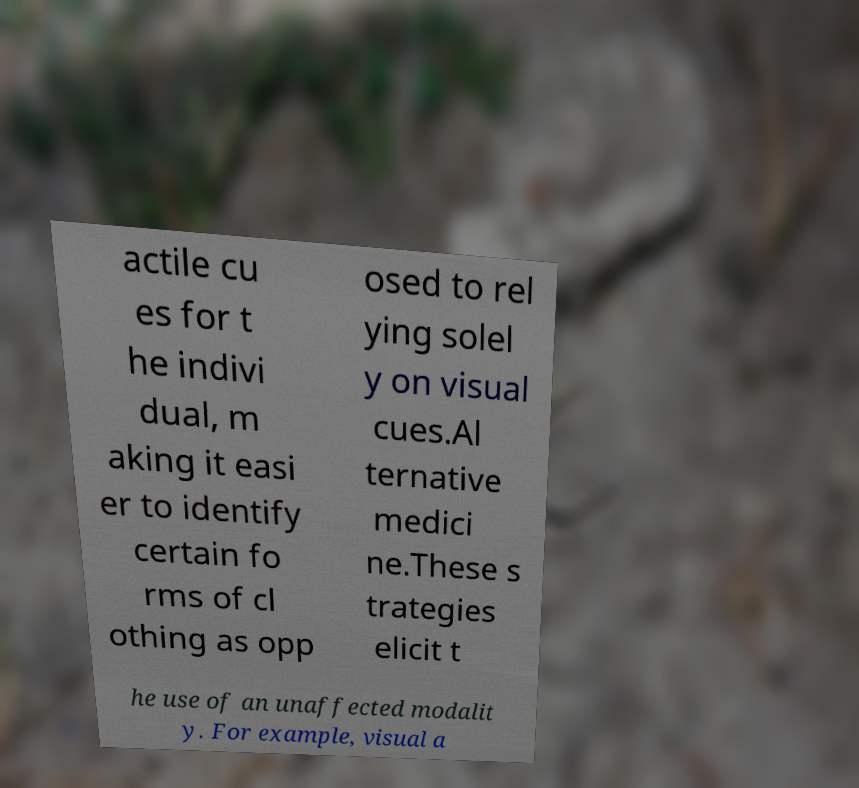What messages or text are displayed in this image? I need them in a readable, typed format. actile cu es for t he indivi dual, m aking it easi er to identify certain fo rms of cl othing as opp osed to rel ying solel y on visual cues.Al ternative medici ne.These s trategies elicit t he use of an unaffected modalit y. For example, visual a 